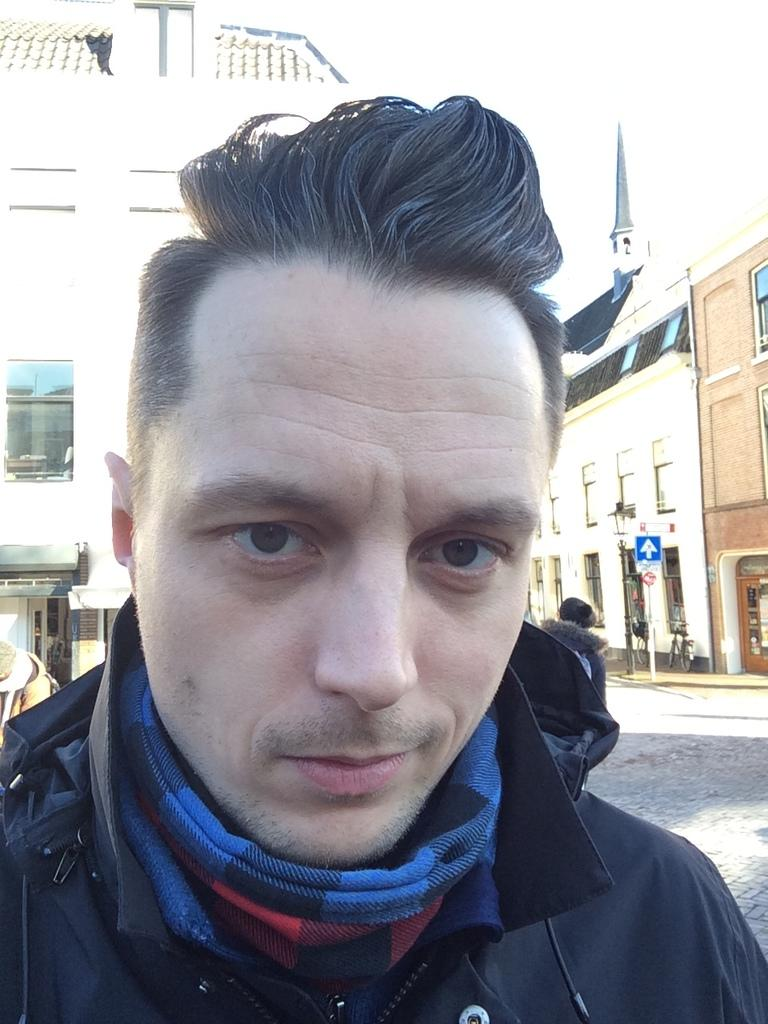Who is present in the image? There is a man in the image. What is the man wearing on his upper body? The man is wearing a black jacket. What accessory is the man wearing around his neck? The man is wearing a scarf. What can be seen in the background of the image? There are buildings in the background of the image. What feature do the buildings have? The buildings have windows. What is at the bottom of the image? There is a road at the bottom of the image. What is visible at the top of the image? The sky is visible at the top of the image. What type of stocking is the man wearing on his hands in the image? The man is not wearing any stockings on his hands in the image; he is wearing a scarf around his neck. 